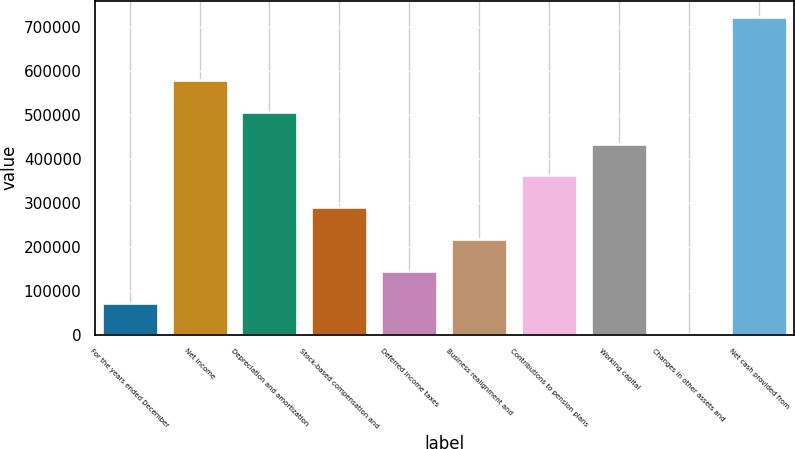<chart> <loc_0><loc_0><loc_500><loc_500><bar_chart><fcel>For the years ended December<fcel>Net income<fcel>Depreciation and amortization<fcel>Stock-based compensation and<fcel>Deferred income taxes<fcel>Business realignment and<fcel>Contributions to pension plans<fcel>Working capital<fcel>Changes in other assets and<fcel>Net cash provided from<nl><fcel>72566.8<fcel>578609<fcel>506318<fcel>289442<fcel>144859<fcel>217150<fcel>361734<fcel>434026<fcel>275<fcel>723193<nl></chart> 